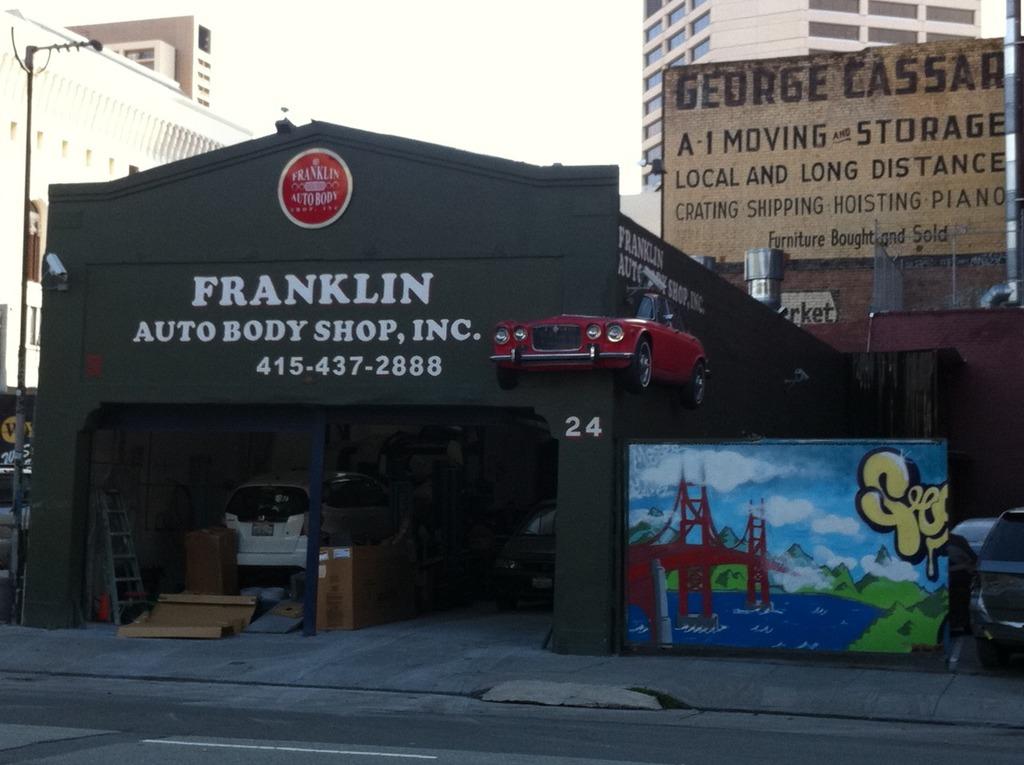What is the name of the body shop?
Give a very brief answer. Franklin. What is the phone number to the shop?
Your answer should be very brief. 415-437-2888. 